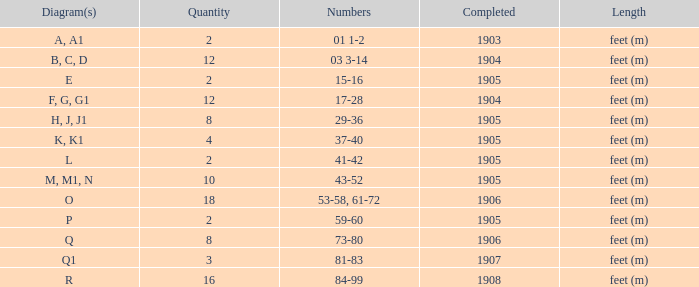What are the numbers for the item completed earlier than 1904? 01 1-2. 